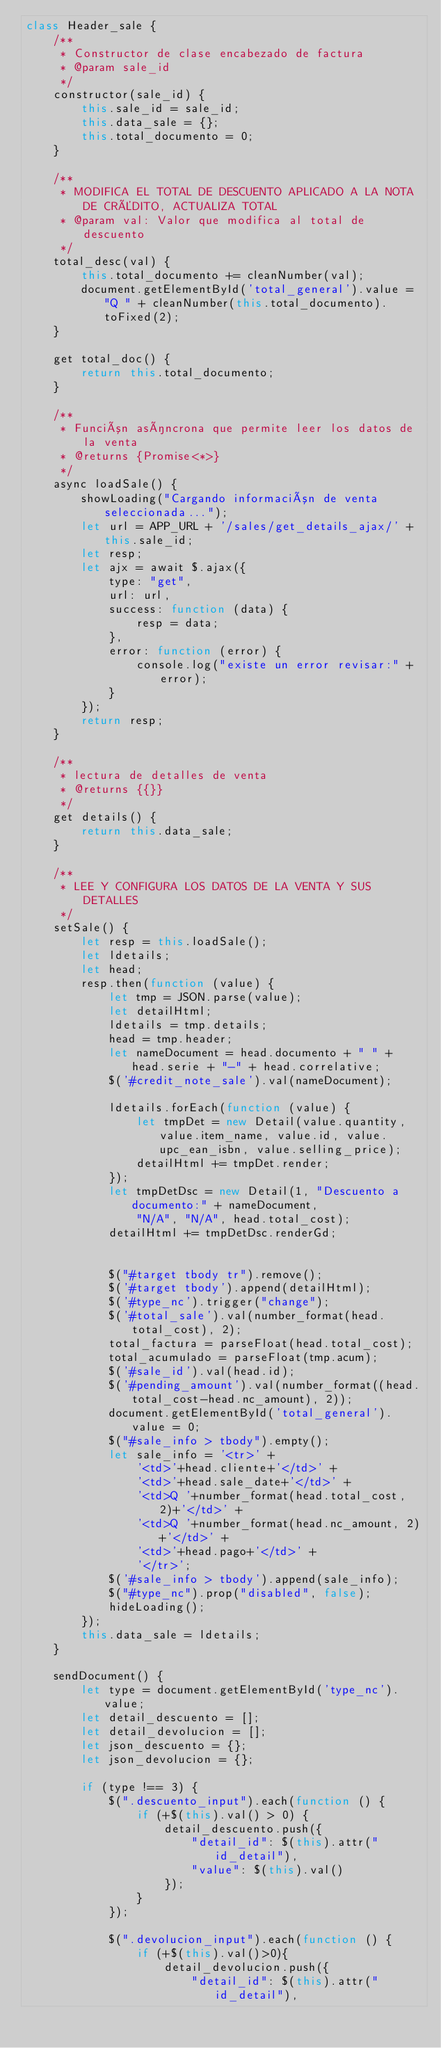Convert code to text. <code><loc_0><loc_0><loc_500><loc_500><_JavaScript_>class Header_sale {
    /**
     * Constructor de clase encabezado de factura
     * @param sale_id
     */
    constructor(sale_id) {
        this.sale_id = sale_id;
        this.data_sale = {};
        this.total_documento = 0;
    }

    /**
     * MODIFICA EL TOTAL DE DESCUENTO APLICADO A LA NOTA DE CRÉDITO, ACTUALIZA TOTAL
     * @param val: Valor que modifica al total de descuento
     */
    total_desc(val) {
        this.total_documento += cleanNumber(val);
        document.getElementById('total_general').value = "Q " + cleanNumber(this.total_documento).toFixed(2);
    }

    get total_doc() {
        return this.total_documento;
    }

    /**
     * Función asíncrona que permite leer los datos de la venta
     * @returns {Promise<*>}
     */
    async loadSale() {
        showLoading("Cargando información de venta seleccionada...");
        let url = APP_URL + '/sales/get_details_ajax/' + this.sale_id;
        let resp;
        let ajx = await $.ajax({
            type: "get",
            url: url,
            success: function (data) {
                resp = data;
            },
            error: function (error) {
                console.log("existe un error revisar:" + error);
            }
        });
        return resp;
    }

    /**
     * lectura de detalles de venta
     * @returns {{}}
     */
    get details() {
        return this.data_sale;
    }

    /**
     * LEE Y CONFIGURA LOS DATOS DE LA VENTA Y SUS DETALLES
     */
    setSale() {
        let resp = this.loadSale();
        let ldetails;
        let head;
        resp.then(function (value) {
            let tmp = JSON.parse(value);
            let detailHtml;
            ldetails = tmp.details;
            head = tmp.header;
            let nameDocument = head.documento + " " + head.serie + "-" + head.correlative;
            $('#credit_note_sale').val(nameDocument);

            ldetails.forEach(function (value) {
                let tmpDet = new Detail(value.quantity, value.item_name, value.id, value.upc_ean_isbn, value.selling_price);
                detailHtml += tmpDet.render;
            });
            let tmpDetDsc = new Detail(1, "Descuento a documento:" + nameDocument,
                "N/A", "N/A", head.total_cost);
            detailHtml += tmpDetDsc.renderGd;


            $("#target tbody tr").remove();
            $('#target tbody').append(detailHtml);
            $('#type_nc').trigger("change");
            $('#total_sale').val(number_format(head.total_cost), 2);
            total_factura = parseFloat(head.total_cost);
            total_acumulado = parseFloat(tmp.acum);
            $('#sale_id').val(head.id);
            $('#pending_amount').val(number_format((head.total_cost-head.nc_amount), 2));
            document.getElementById('total_general').value = 0;
            $("#sale_info > tbody").empty();
            let sale_info = '<tr>' +
                '<td>'+head.cliente+'</td>' +
                '<td>'+head.sale_date+'</td>' +
                '<td>Q '+number_format(head.total_cost, 2)+'</td>' +
                '<td>Q '+number_format(head.nc_amount, 2)+'</td>' +
                '<td>'+head.pago+'</td>' +
                '</tr>';
            $('#sale_info > tbody').append(sale_info);
            $("#type_nc").prop("disabled", false);
            hideLoading();
        });
        this.data_sale = ldetails;
    }

    sendDocument() {
        let type = document.getElementById('type_nc').value;
        let detail_descuento = [];
        let detail_devolucion = [];
        let json_descuento = {};
        let json_devolucion = {};

        if (type !== 3) {
            $(".descuento_input").each(function () {
                if (+$(this).val() > 0) {
                    detail_descuento.push({
                        "detail_id": $(this).attr("id_detail"),
                        "value": $(this).val()
                    });
                }
            });

            $(".devolucion_input").each(function () {
                if (+$(this).val()>0){
                    detail_devolucion.push({
                        "detail_id": $(this).attr("id_detail"),</code> 